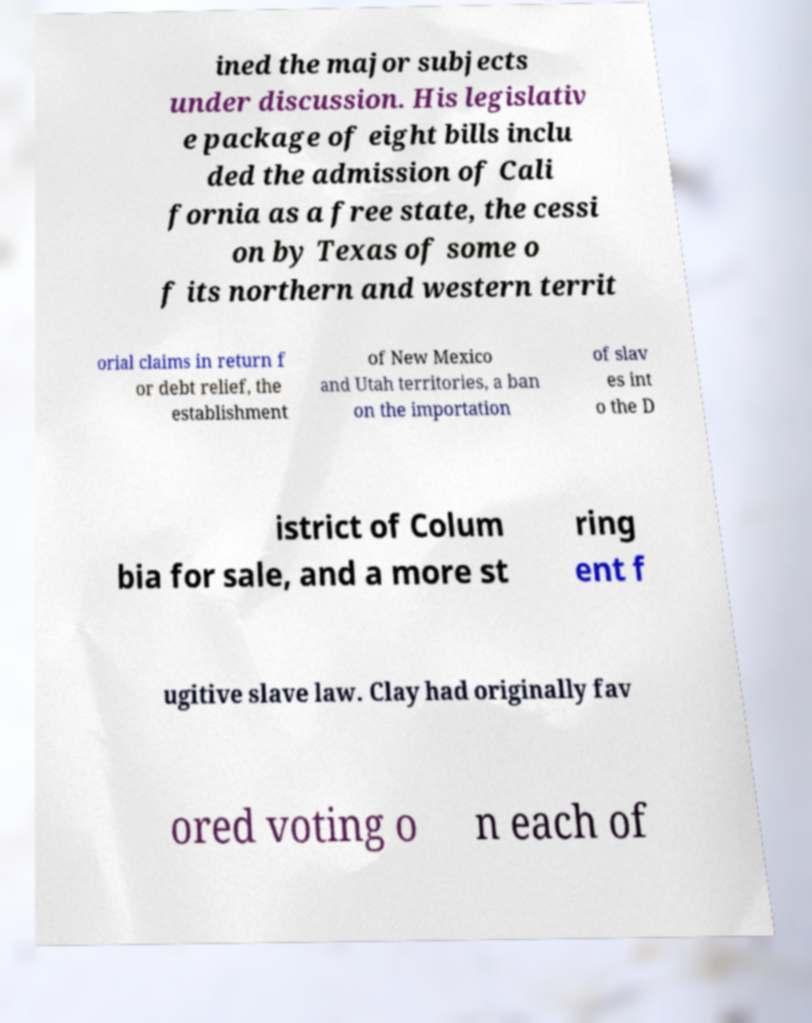Could you assist in decoding the text presented in this image and type it out clearly? ined the major subjects under discussion. His legislativ e package of eight bills inclu ded the admission of Cali fornia as a free state, the cessi on by Texas of some o f its northern and western territ orial claims in return f or debt relief, the establishment of New Mexico and Utah territories, a ban on the importation of slav es int o the D istrict of Colum bia for sale, and a more st ring ent f ugitive slave law. Clay had originally fav ored voting o n each of 